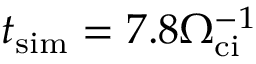Convert formula to latex. <formula><loc_0><loc_0><loc_500><loc_500>t _ { s i m } = 7 . 8 \Omega _ { c i } ^ { - 1 }</formula> 